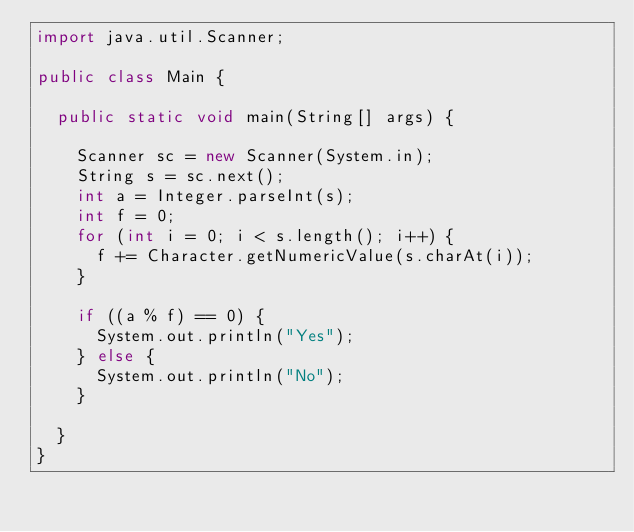<code> <loc_0><loc_0><loc_500><loc_500><_Java_>import java.util.Scanner;

public class Main {

  public static void main(String[] args) {

    Scanner sc = new Scanner(System.in);
    String s = sc.next();
    int a = Integer.parseInt(s);
    int f = 0;
    for (int i = 0; i < s.length(); i++) {
      f += Character.getNumericValue(s.charAt(i));
    }

    if ((a % f) == 0) {
      System.out.println("Yes");
    } else {
      System.out.println("No");
    }

  }
}</code> 